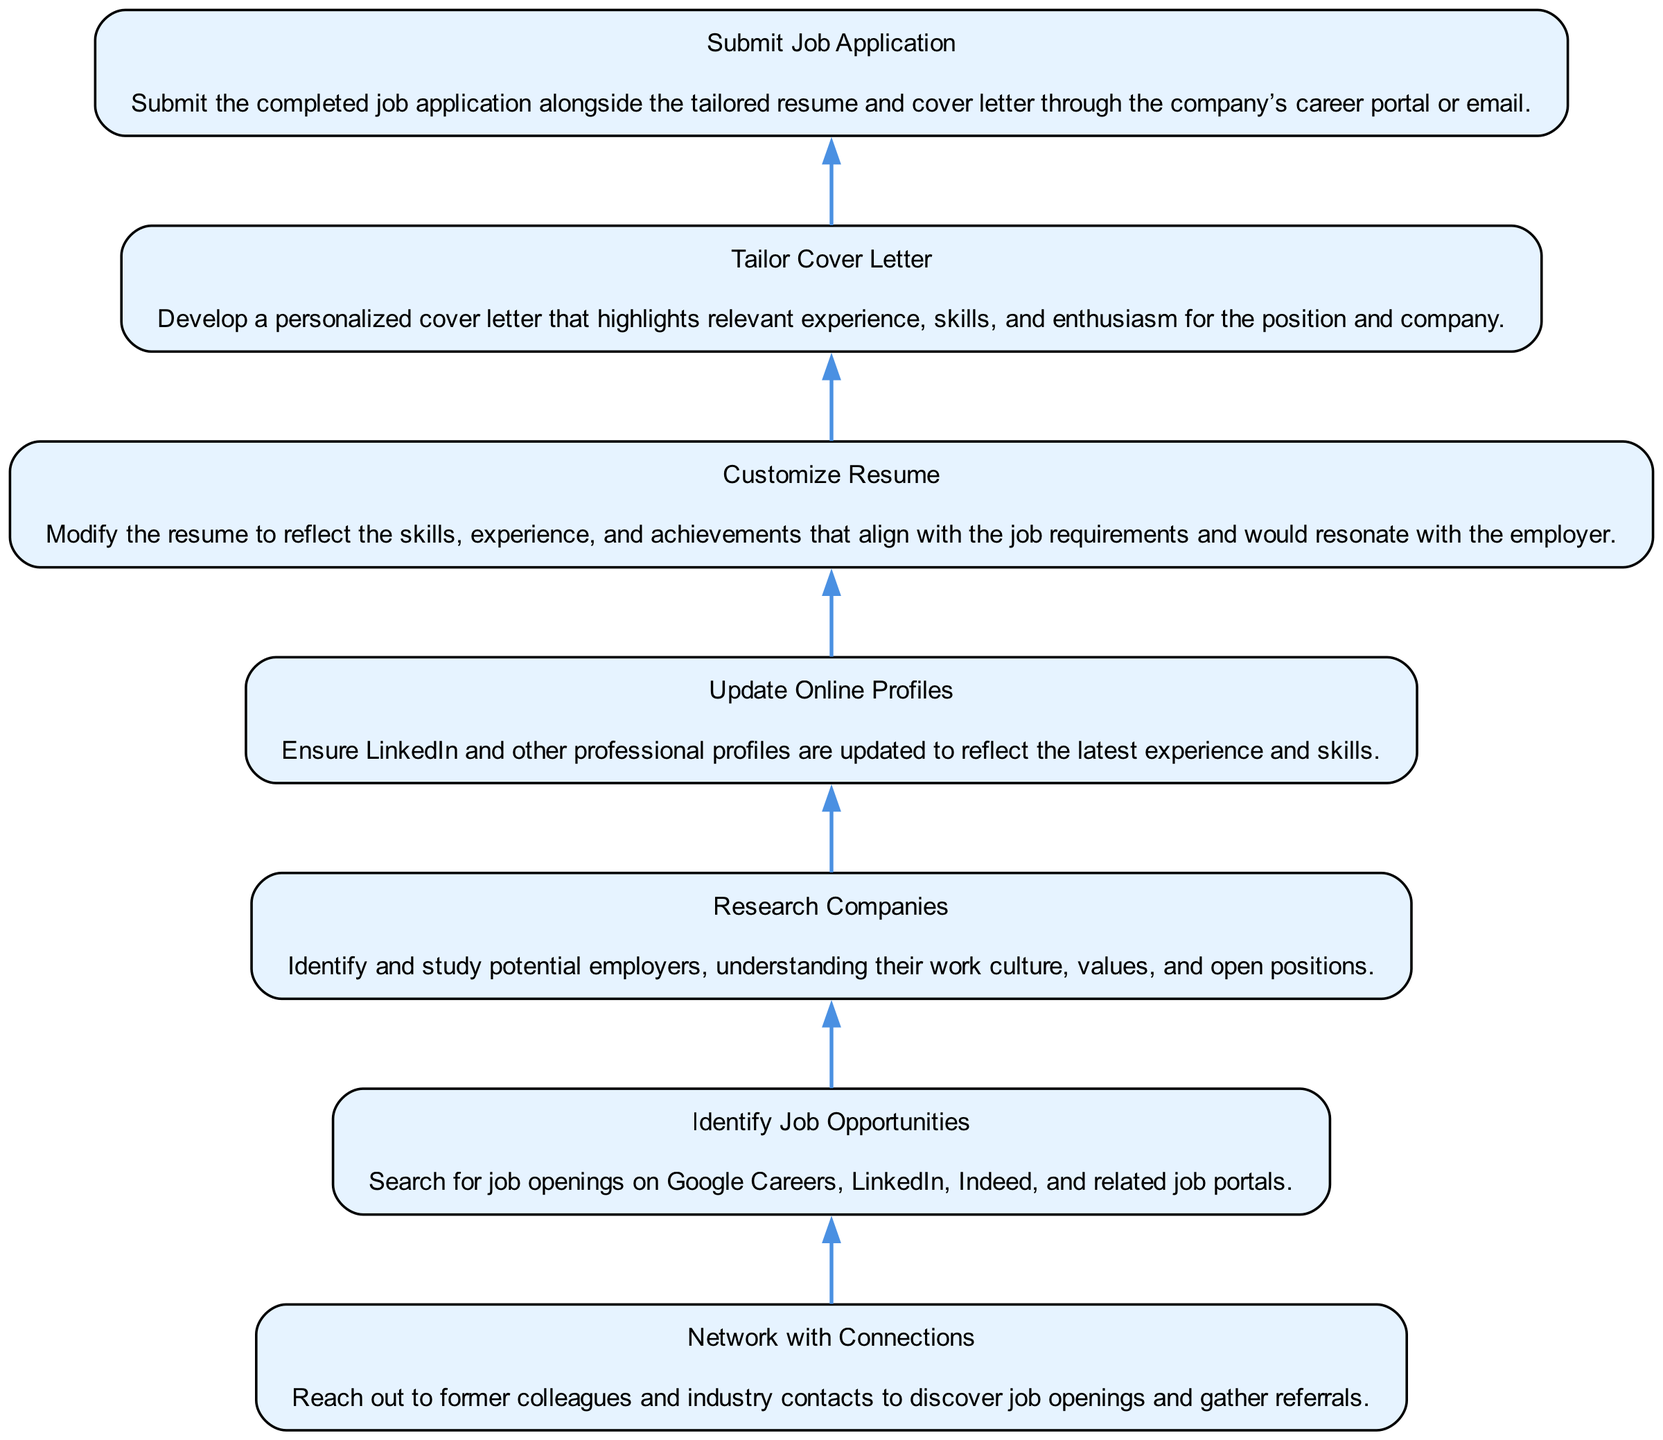What is the topmost action in the diagram? The topmost action displays "Submit Job Application," indicating it is the final step in the outlined process.
Answer: Submit Job Application How many nodes are present in the diagram? By counting each individual step from the bottom to the top, there are a total of 7 nodes representing the different actions in the job application process.
Answer: 7 What action comes immediately before "Submit Job Application"? The flow of the diagram shows that "Customize Resume" is the immediate precursor to "Submit Job Application," indicating that tailoring the resume is a necessary step prior to submission.
Answer: Customize Resume Which action entails reaching out to former colleagues? The step titled "Network with Connections" clearly indicates the action of connecting with former colleagues and industry contacts for job opportunities and referrals.
Answer: Network with Connections What is the relationship between "Research Companies" and "Identify Job Opportunities"? "Research Companies" supports "Identify Job Opportunities" as it involves understanding potential employers, which ultimately helps in locating relevant job openings.
Answer: Research Companies supports Identify Job Opportunities How does the flow of this diagram indicate the importance of networking? The flow indicates that "Network with Connections" is one of the first steps after identifying job opportunities, emphasizing that networking plays a crucial role in the job application process before submitting applications.
Answer: Networking is crucial before submission What should be done after "Update Online Profiles"? The process indicates that once "Update Online Profiles" is complete, the next step is "Submit Job Application," showing the sequence of completing online presence before applying for jobs.
Answer: Submit Job Application What two actions relate directly to tailoring job application materials? "Tailor Cover Letter" and "Customize Resume" are the two actions specifically focused on personalizing application materials for the job in question.
Answer: Tailor Cover Letter and Customize Resume 